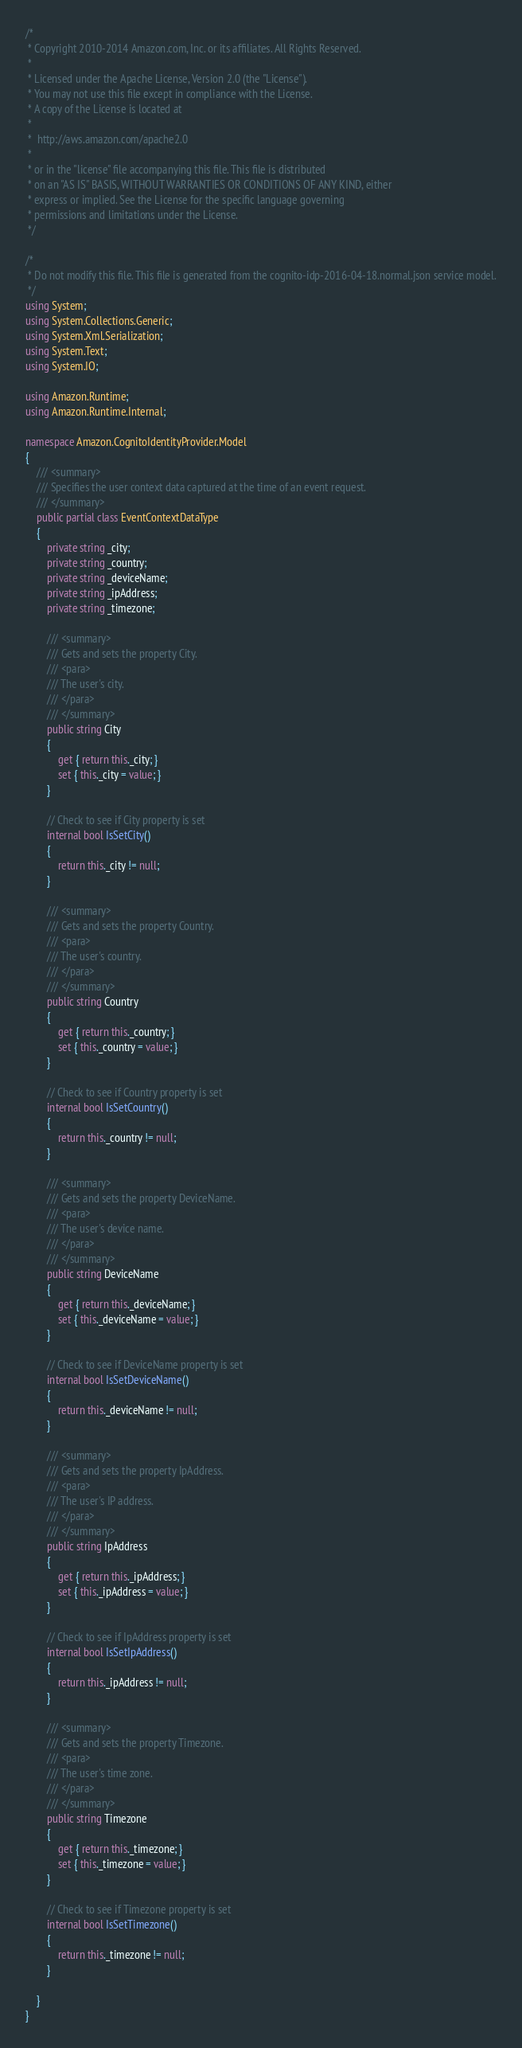Convert code to text. <code><loc_0><loc_0><loc_500><loc_500><_C#_>/*
 * Copyright 2010-2014 Amazon.com, Inc. or its affiliates. All Rights Reserved.
 * 
 * Licensed under the Apache License, Version 2.0 (the "License").
 * You may not use this file except in compliance with the License.
 * A copy of the License is located at
 * 
 *  http://aws.amazon.com/apache2.0
 * 
 * or in the "license" file accompanying this file. This file is distributed
 * on an "AS IS" BASIS, WITHOUT WARRANTIES OR CONDITIONS OF ANY KIND, either
 * express or implied. See the License for the specific language governing
 * permissions and limitations under the License.
 */

/*
 * Do not modify this file. This file is generated from the cognito-idp-2016-04-18.normal.json service model.
 */
using System;
using System.Collections.Generic;
using System.Xml.Serialization;
using System.Text;
using System.IO;

using Amazon.Runtime;
using Amazon.Runtime.Internal;

namespace Amazon.CognitoIdentityProvider.Model
{
    /// <summary>
    /// Specifies the user context data captured at the time of an event request.
    /// </summary>
    public partial class EventContextDataType
    {
        private string _city;
        private string _country;
        private string _deviceName;
        private string _ipAddress;
        private string _timezone;

        /// <summary>
        /// Gets and sets the property City. 
        /// <para>
        /// The user's city.
        /// </para>
        /// </summary>
        public string City
        {
            get { return this._city; }
            set { this._city = value; }
        }

        // Check to see if City property is set
        internal bool IsSetCity()
        {
            return this._city != null;
        }

        /// <summary>
        /// Gets and sets the property Country. 
        /// <para>
        /// The user's country.
        /// </para>
        /// </summary>
        public string Country
        {
            get { return this._country; }
            set { this._country = value; }
        }

        // Check to see if Country property is set
        internal bool IsSetCountry()
        {
            return this._country != null;
        }

        /// <summary>
        /// Gets and sets the property DeviceName. 
        /// <para>
        /// The user's device name.
        /// </para>
        /// </summary>
        public string DeviceName
        {
            get { return this._deviceName; }
            set { this._deviceName = value; }
        }

        // Check to see if DeviceName property is set
        internal bool IsSetDeviceName()
        {
            return this._deviceName != null;
        }

        /// <summary>
        /// Gets and sets the property IpAddress. 
        /// <para>
        /// The user's IP address.
        /// </para>
        /// </summary>
        public string IpAddress
        {
            get { return this._ipAddress; }
            set { this._ipAddress = value; }
        }

        // Check to see if IpAddress property is set
        internal bool IsSetIpAddress()
        {
            return this._ipAddress != null;
        }

        /// <summary>
        /// Gets and sets the property Timezone. 
        /// <para>
        /// The user's time zone.
        /// </para>
        /// </summary>
        public string Timezone
        {
            get { return this._timezone; }
            set { this._timezone = value; }
        }

        // Check to see if Timezone property is set
        internal bool IsSetTimezone()
        {
            return this._timezone != null;
        }

    }
}</code> 